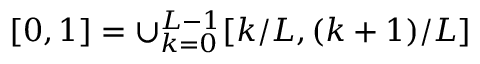<formula> <loc_0><loc_0><loc_500><loc_500>[ 0 , 1 ] = \cup _ { k = 0 } ^ { L - 1 } [ k / L , ( k + 1 ) / L ]</formula> 